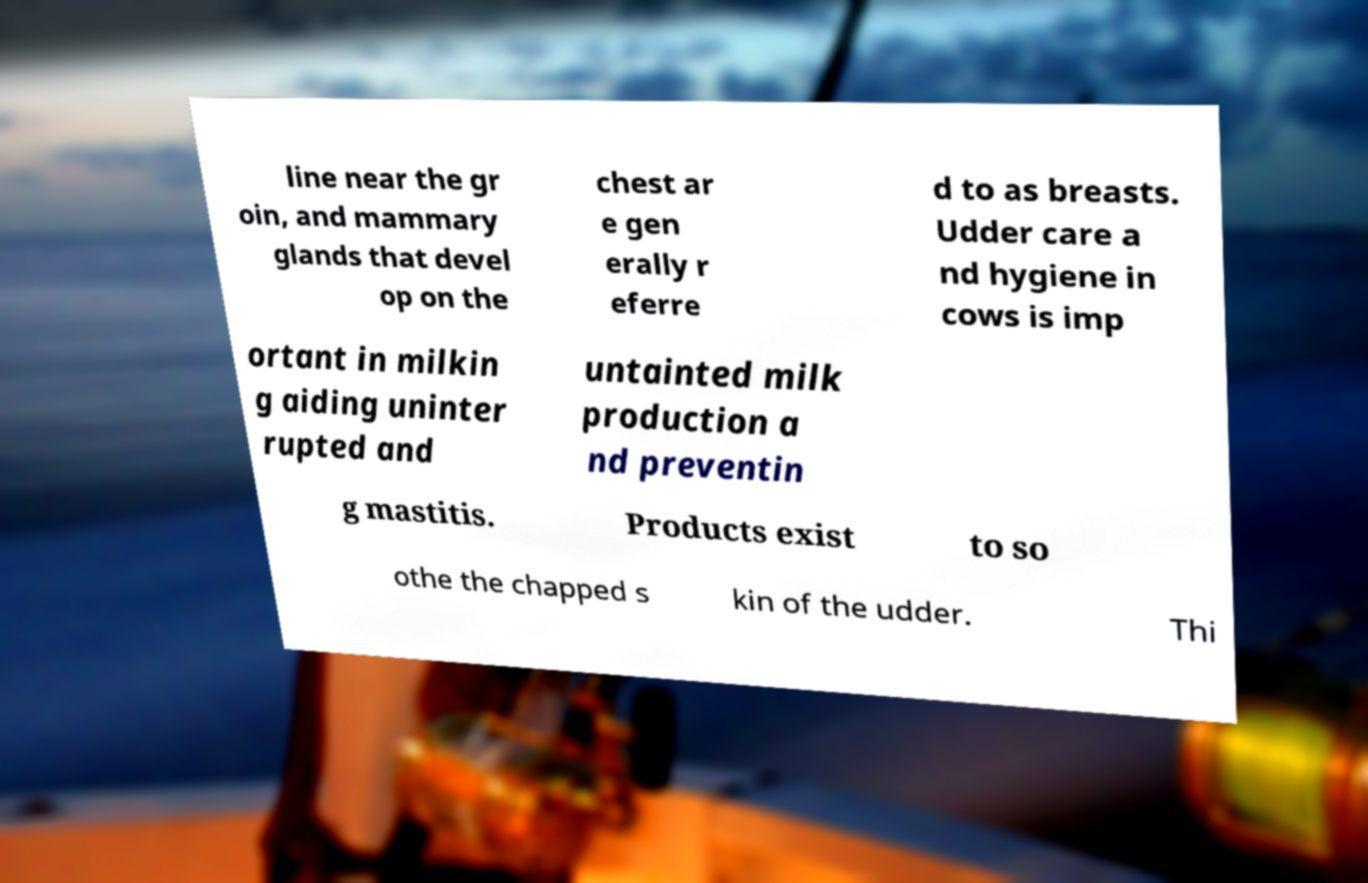Can you accurately transcribe the text from the provided image for me? line near the gr oin, and mammary glands that devel op on the chest ar e gen erally r eferre d to as breasts. Udder care a nd hygiene in cows is imp ortant in milkin g aiding uninter rupted and untainted milk production a nd preventin g mastitis. Products exist to so othe the chapped s kin of the udder. Thi 